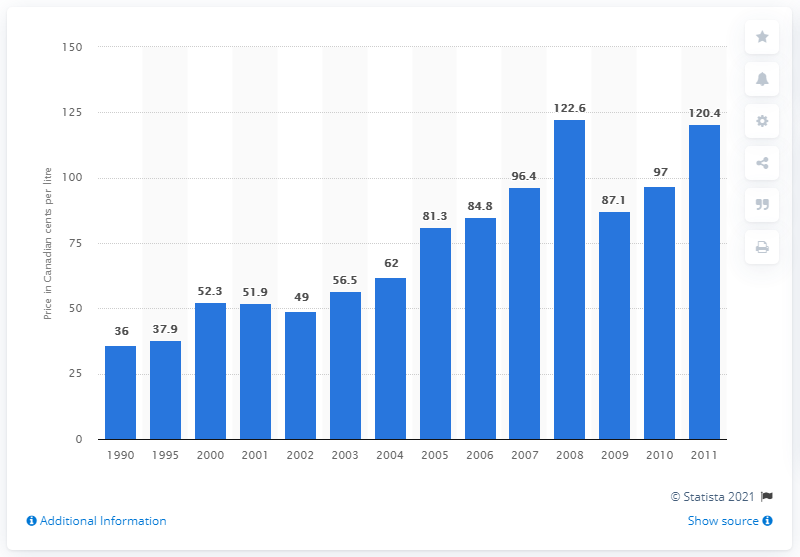Draw attention to some important aspects in this diagram. The price per litre of home heating oil in Yellowknife in 2000 was 52.3 cents. 